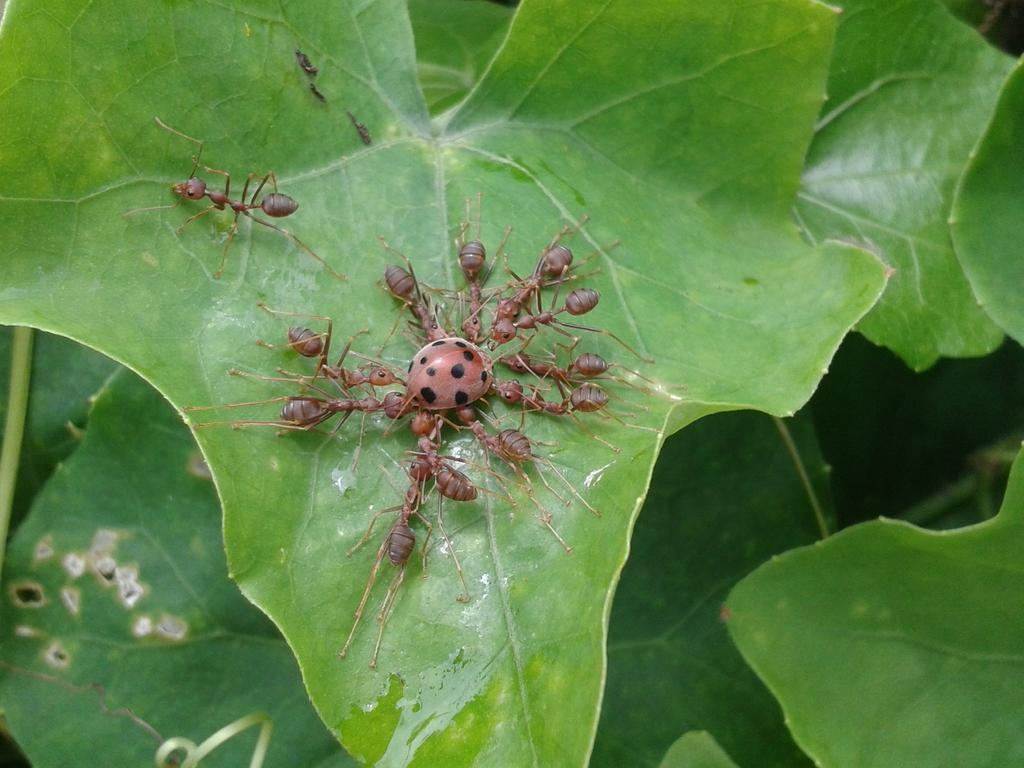What type of vegetation can be seen in the image? There are leaves in the image. Is there any wildlife present on the leaves? Yes, there is a bug on one of the leaves. What can be observed on the leaf with the bug? There are black dots on the leaf with the bug. Are there any other insects or creatures in the image? Yes, there are ants around the bug. What is the color of the ants? The ants are brown in color. What type of hook can be seen hanging from the leaf in the image? There is no hook present in the image; it features leaves, a bug, black dots, and ants. Is there a bomb visible in the image? No, there is no bomb present in the image. 